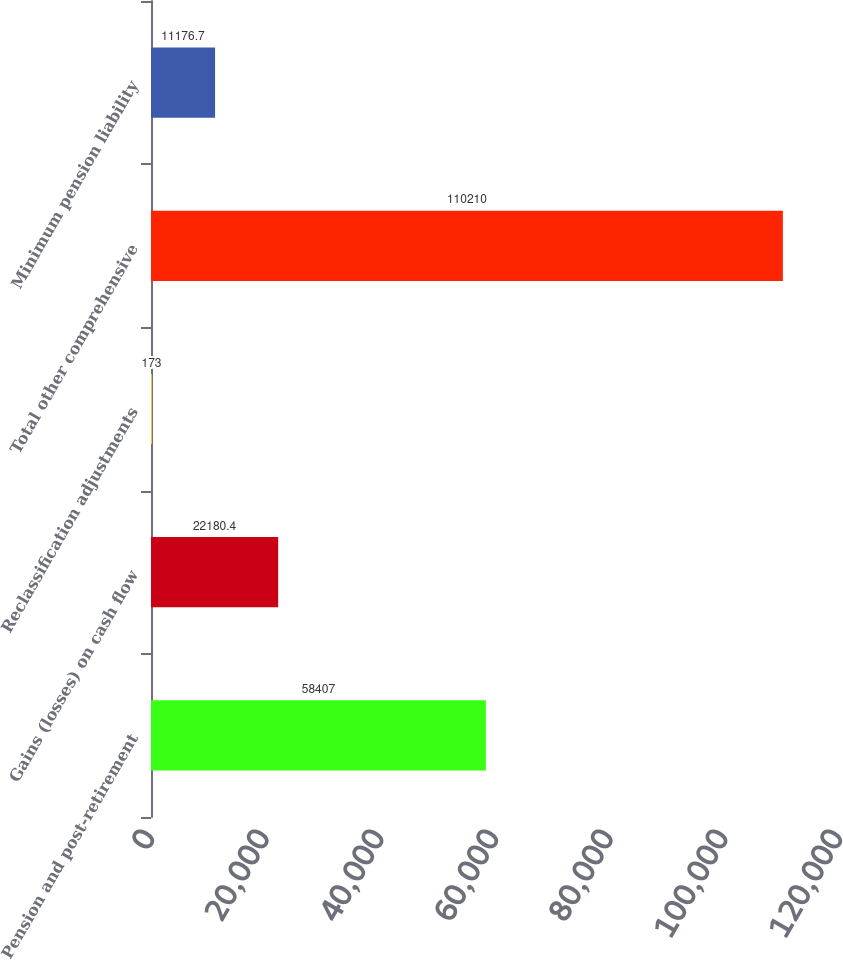Convert chart to OTSL. <chart><loc_0><loc_0><loc_500><loc_500><bar_chart><fcel>Pension and post-retirement<fcel>Gains (losses) on cash flow<fcel>Reclassification adjustments<fcel>Total other comprehensive<fcel>Minimum pension liability<nl><fcel>58407<fcel>22180.4<fcel>173<fcel>110210<fcel>11176.7<nl></chart> 